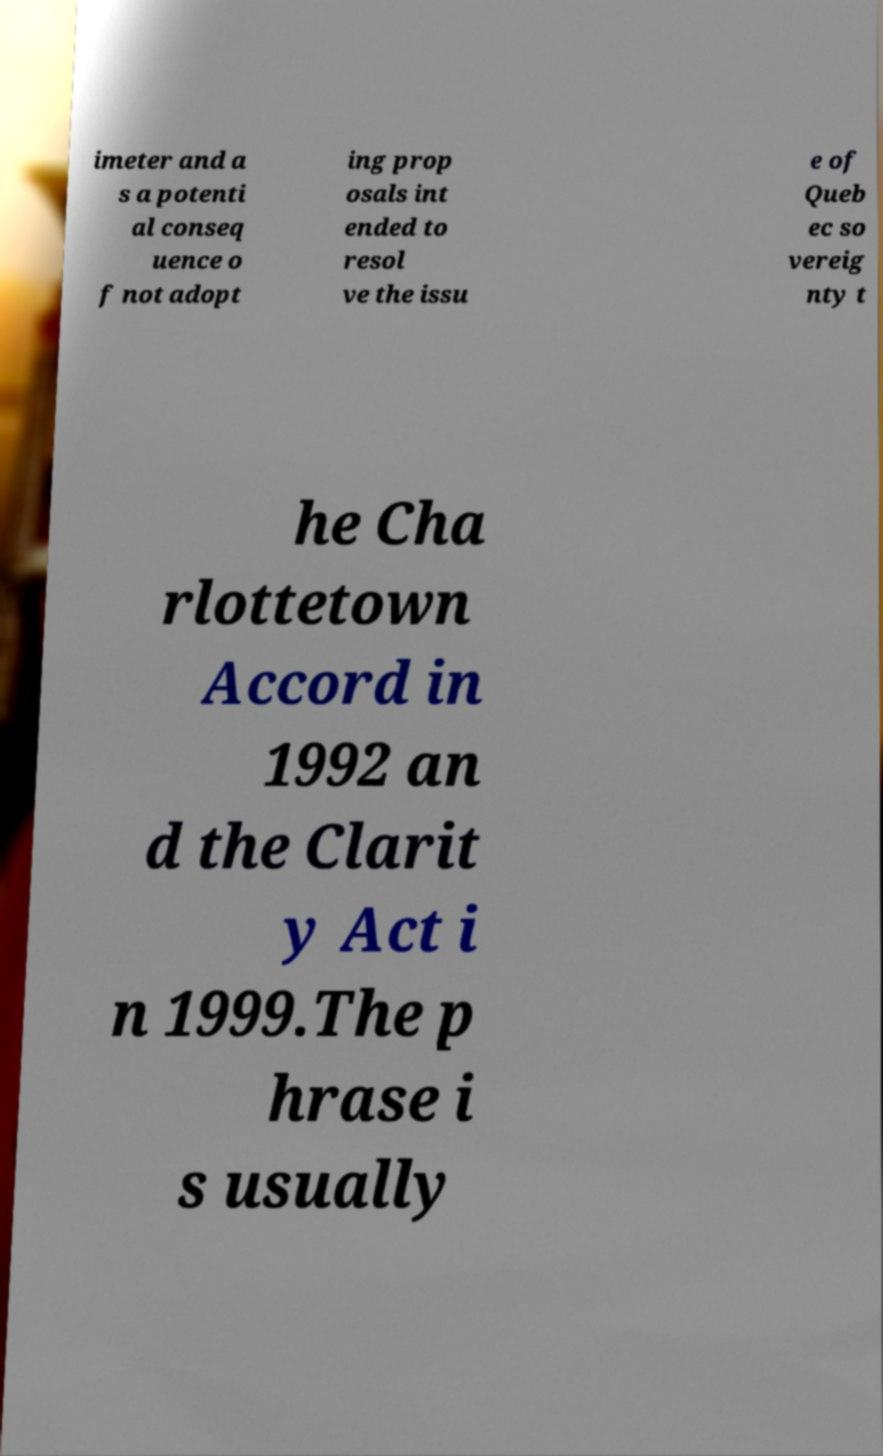I need the written content from this picture converted into text. Can you do that? imeter and a s a potenti al conseq uence o f not adopt ing prop osals int ended to resol ve the issu e of Queb ec so vereig nty t he Cha rlottetown Accord in 1992 an d the Clarit y Act i n 1999.The p hrase i s usually 